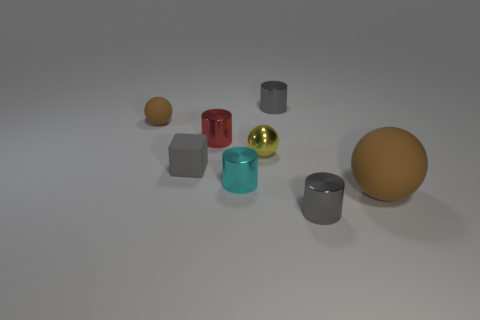Is the number of big brown matte spheres less than the number of rubber things?
Ensure brevity in your answer.  Yes. Is the shape of the big brown thing the same as the small gray matte thing?
Provide a short and direct response. No. How many things are cyan metal objects or matte objects on the left side of the big brown rubber sphere?
Provide a succinct answer. 3. How many tiny cylinders are there?
Provide a succinct answer. 4. Is there a red cylinder of the same size as the yellow shiny ball?
Ensure brevity in your answer.  Yes. Is the number of gray cylinders that are to the right of the large rubber ball less than the number of large red matte cylinders?
Your answer should be compact. No. The cyan cylinder that is made of the same material as the yellow object is what size?
Your answer should be compact. Small. How many tiny metallic cylinders are the same color as the tiny block?
Keep it short and to the point. 2. Is the number of small gray metallic objects that are on the left side of the small rubber sphere less than the number of big brown rubber things that are in front of the red cylinder?
Your answer should be compact. Yes. There is a tiny gray object that is behind the small brown rubber sphere; does it have the same shape as the cyan object?
Offer a terse response. Yes. 